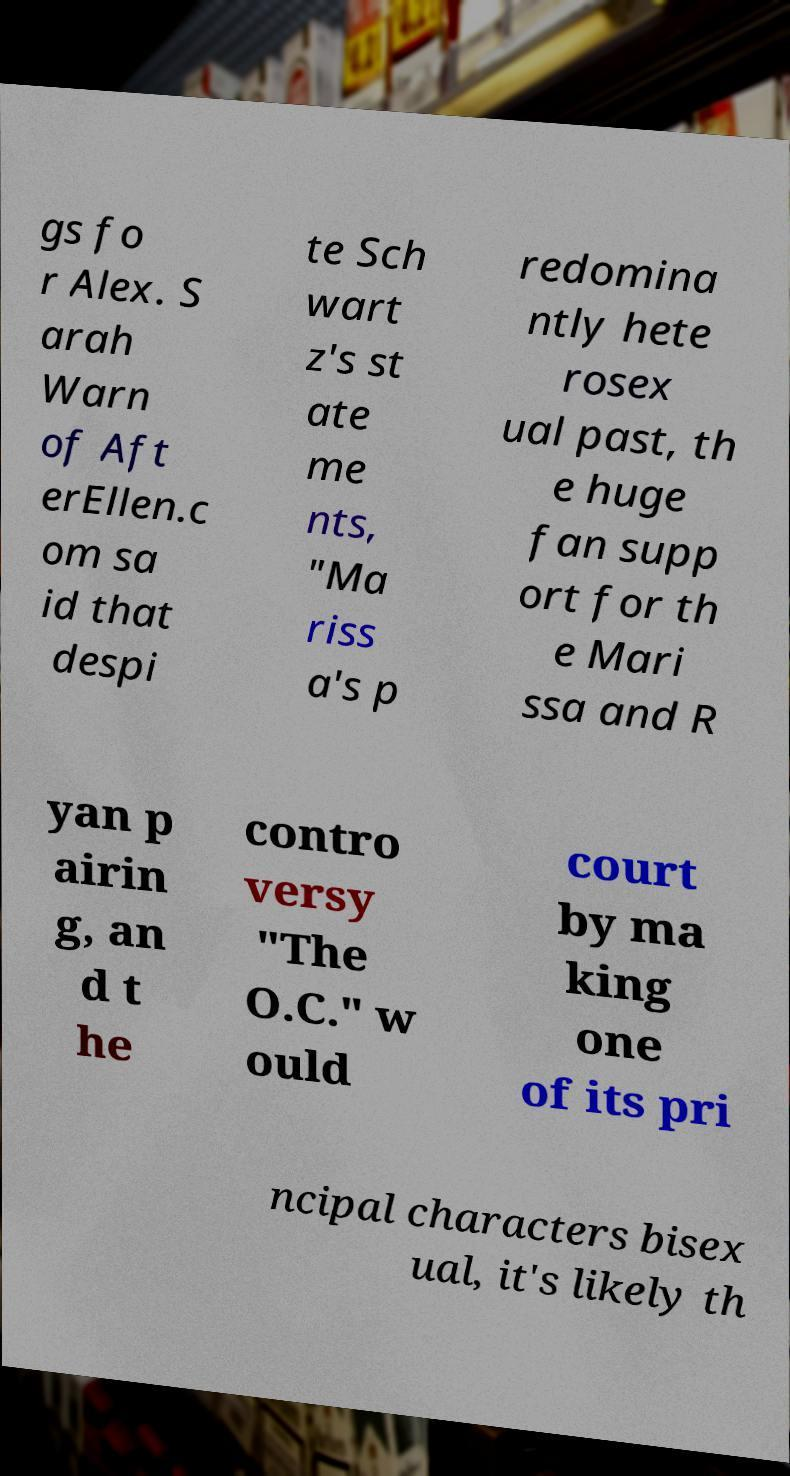Could you extract and type out the text from this image? gs fo r Alex. S arah Warn of Aft erEllen.c om sa id that despi te Sch wart z's st ate me nts, "Ma riss a's p redomina ntly hete rosex ual past, th e huge fan supp ort for th e Mari ssa and R yan p airin g, an d t he contro versy "The O.C." w ould court by ma king one of its pri ncipal characters bisex ual, it's likely th 